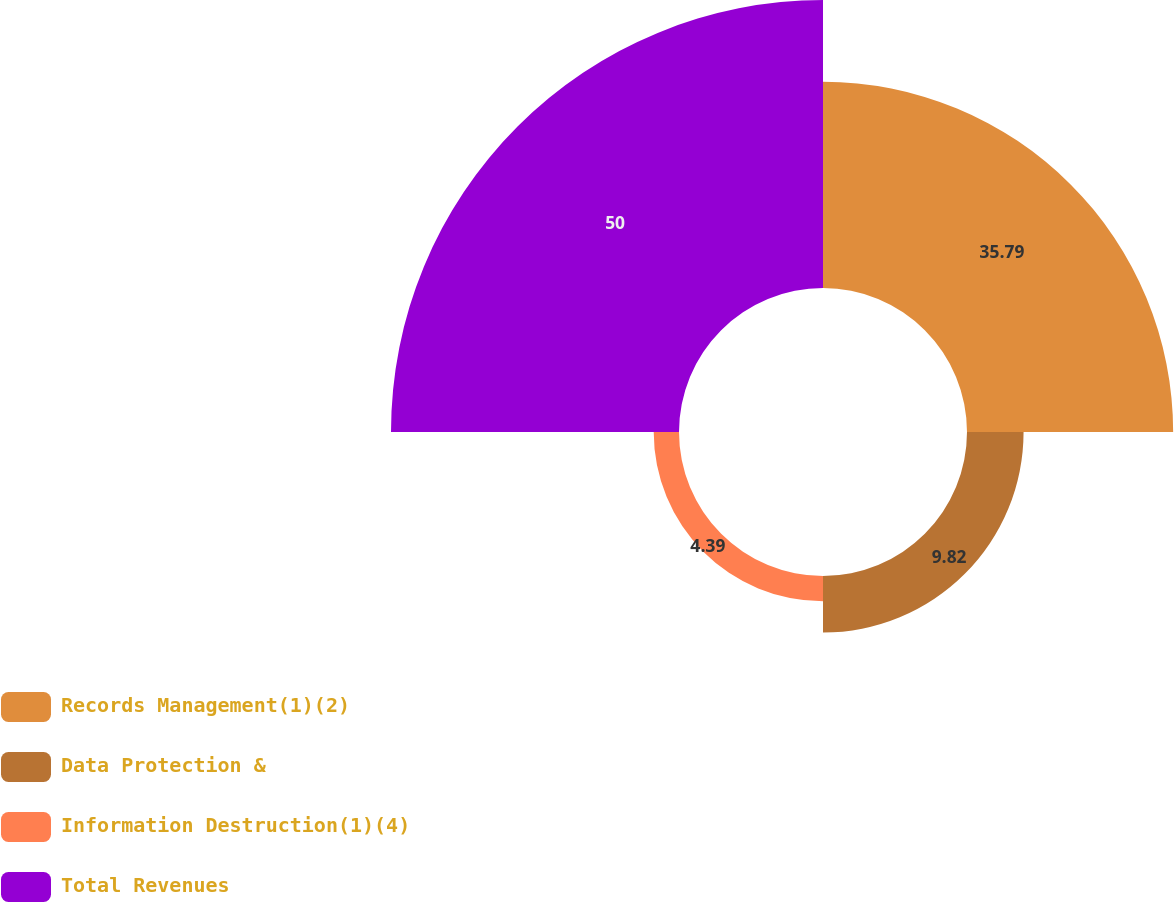Convert chart. <chart><loc_0><loc_0><loc_500><loc_500><pie_chart><fcel>Records Management(1)(2)<fcel>Data Protection &<fcel>Information Destruction(1)(4)<fcel>Total Revenues<nl><fcel>35.79%<fcel>9.82%<fcel>4.39%<fcel>50.0%<nl></chart> 